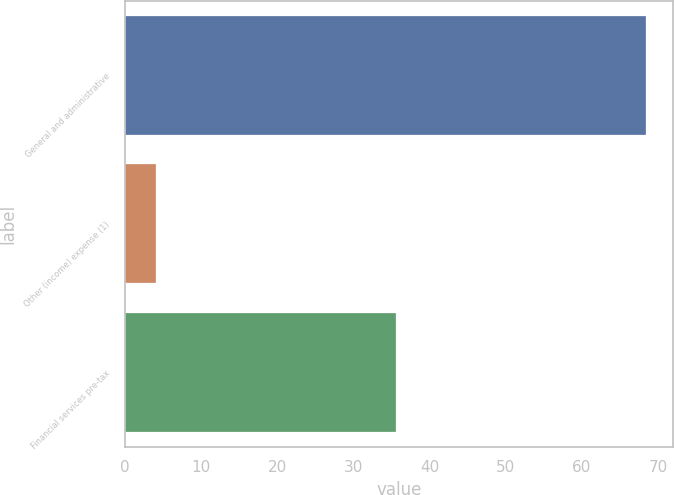Convert chart to OTSL. <chart><loc_0><loc_0><loc_500><loc_500><bar_chart><fcel>General and administrative<fcel>Other (income) expense (1)<fcel>Financial services pre-tax<nl><fcel>68.5<fcel>4.1<fcel>35.6<nl></chart> 